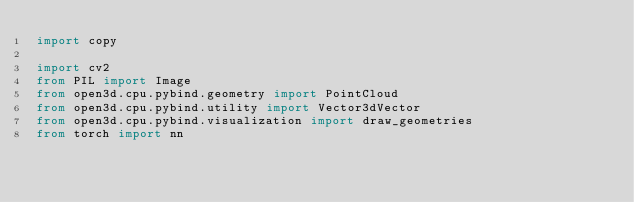Convert code to text. <code><loc_0><loc_0><loc_500><loc_500><_Python_>import copy

import cv2
from PIL import Image
from open3d.cpu.pybind.geometry import PointCloud
from open3d.cpu.pybind.utility import Vector3dVector
from open3d.cpu.pybind.visualization import draw_geometries
from torch import nn</code> 